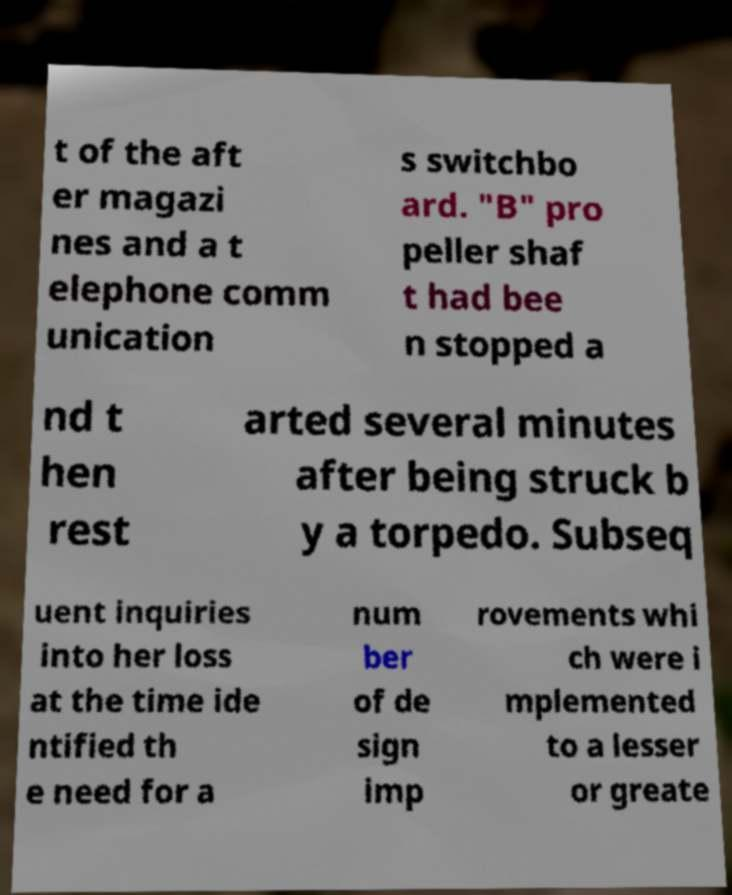Please identify and transcribe the text found in this image. t of the aft er magazi nes and a t elephone comm unication s switchbo ard. "B" pro peller shaf t had bee n stopped a nd t hen rest arted several minutes after being struck b y a torpedo. Subseq uent inquiries into her loss at the time ide ntified th e need for a num ber of de sign imp rovements whi ch were i mplemented to a lesser or greate 